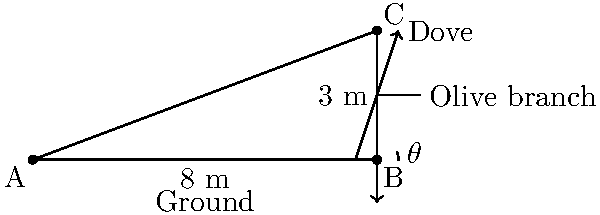A dove, symbolizing peace, is flying towards an olive branch on a tree. The olive branch is 3 meters above the ground, and the base of the tree is 8 meters away from an observer. What is the angle of elevation ($\theta$) at which the observer sees the dove as it approaches the olive branch? To find the angle of elevation, we need to use trigonometry. Let's approach this step-by-step:

1) We have a right triangle formed by:
   - The horizontal distance from the observer to the tree (adjacent side)
   - The height of the olive branch (opposite side)
   - The line of sight from the observer to the dove (hypotenuse)

2) We know:
   - Adjacent side (ground distance) = 8 meters
   - Opposite side (height of olive branch) = 3 meters

3) To find the angle of elevation ($\theta$), we need to use the tangent function:

   $\tan(\theta) = \frac{\text{opposite}}{\text{adjacent}}$

4) Plugging in our values:

   $\tan(\theta) = \frac{3}{8}$

5) To solve for $\theta$, we need to use the inverse tangent (arctan or $\tan^{-1}$):

   $\theta = \tan^{-1}(\frac{3}{8})$

6) Using a calculator or trigonometric tables:

   $\theta \approx 20.56°$

Therefore, the angle of elevation at which the observer sees the dove approaching the olive branch is approximately 20.56°.
Answer: $20.56°$ 